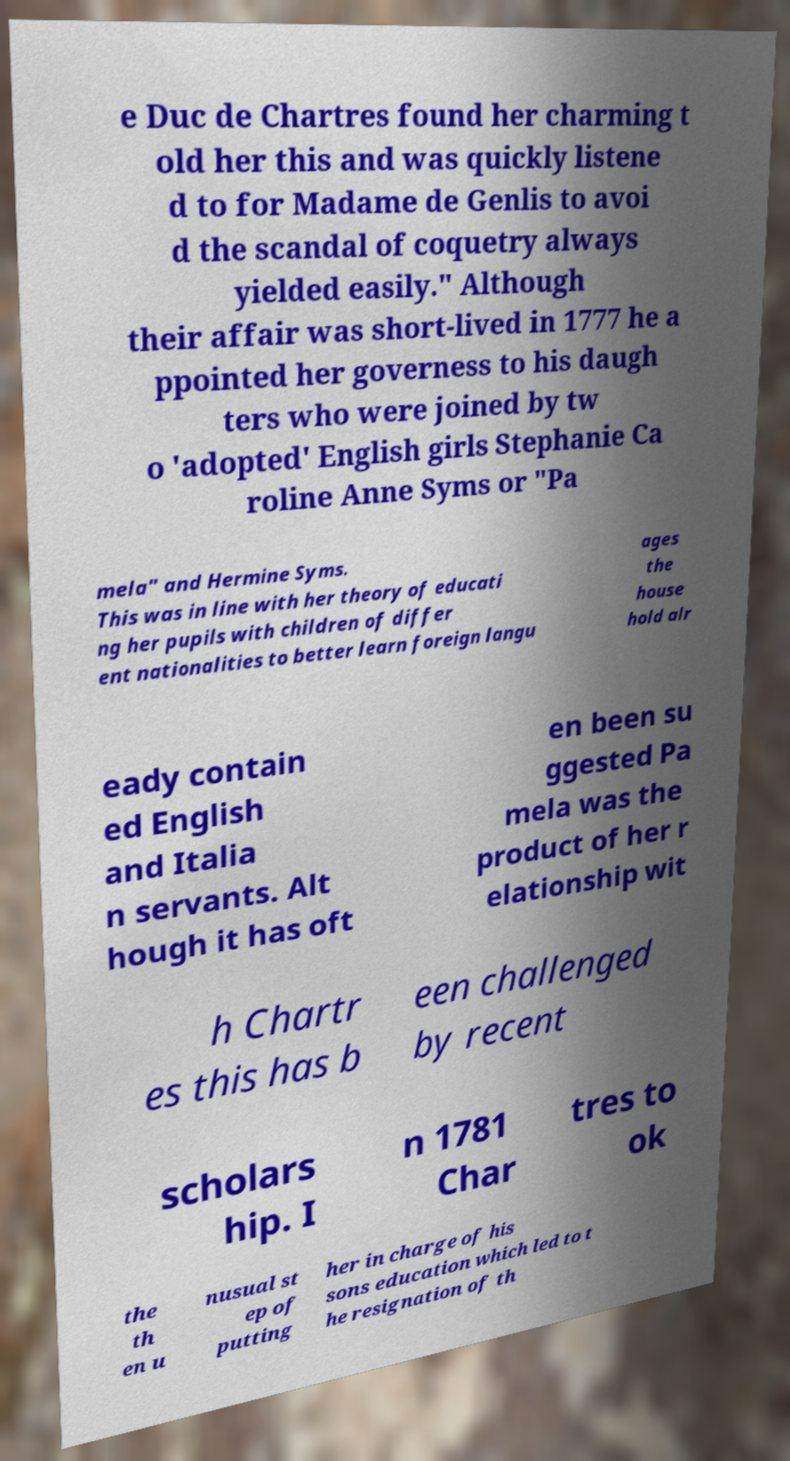For documentation purposes, I need the text within this image transcribed. Could you provide that? e Duc de Chartres found her charming t old her this and was quickly listene d to for Madame de Genlis to avoi d the scandal of coquetry always yielded easily." Although their affair was short-lived in 1777 he a ppointed her governess to his daugh ters who were joined by tw o 'adopted' English girls Stephanie Ca roline Anne Syms or "Pa mela" and Hermine Syms. This was in line with her theory of educati ng her pupils with children of differ ent nationalities to better learn foreign langu ages the house hold alr eady contain ed English and Italia n servants. Alt hough it has oft en been su ggested Pa mela was the product of her r elationship wit h Chartr es this has b een challenged by recent scholars hip. I n 1781 Char tres to ok the th en u nusual st ep of putting her in charge of his sons education which led to t he resignation of th 